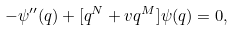Convert formula to latex. <formula><loc_0><loc_0><loc_500><loc_500>- \psi ^ { \prime \prime } ( q ) + [ q ^ { N } + v q ^ { M } ] \psi ( q ) = 0 ,</formula> 